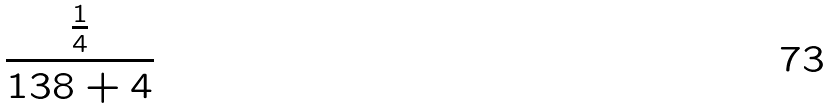Convert formula to latex. <formula><loc_0><loc_0><loc_500><loc_500>\frac { \frac { 1 } { 4 } } { 1 3 8 + 4 }</formula> 